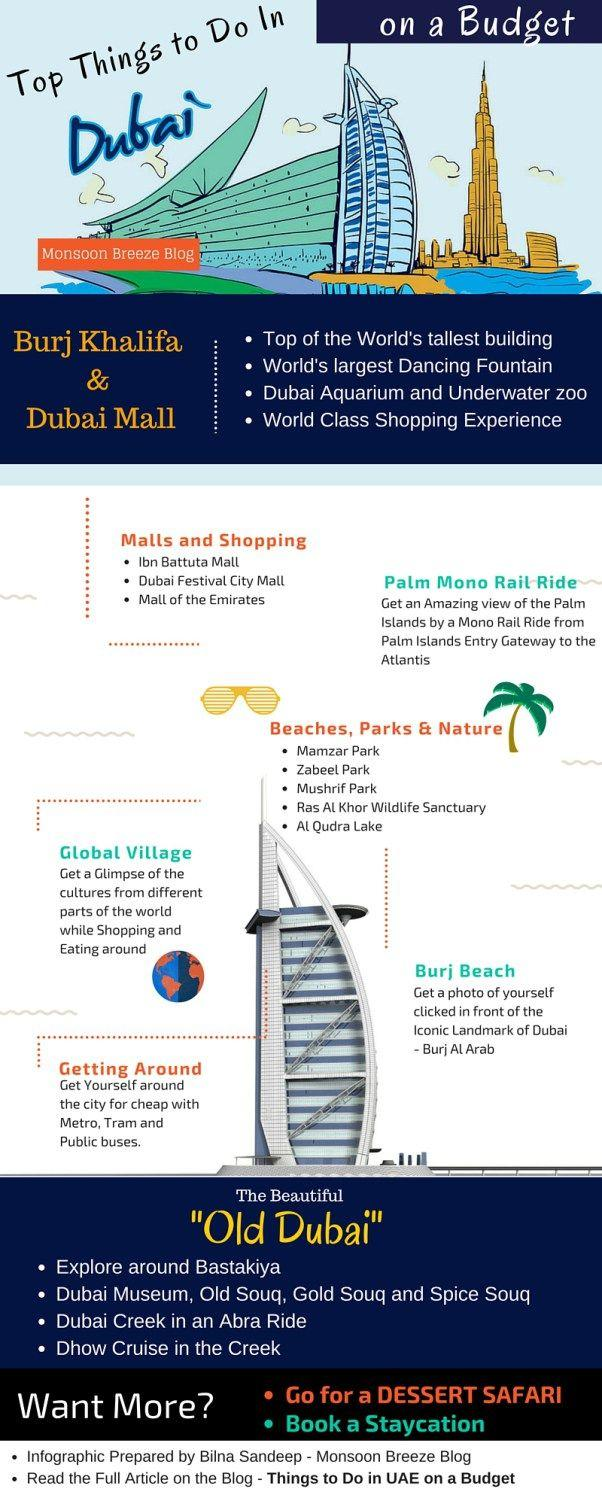Specify some key components in this picture. Bastakiya, an old neighborhood in Dubai, is located where. There are three souqs mentioned in this text. The world's largest dancing fountain can be found in Dubai Mall. The modes of transportation include the metro, tram, and public busses. There have been 4 malls mentioned in this conversation. 